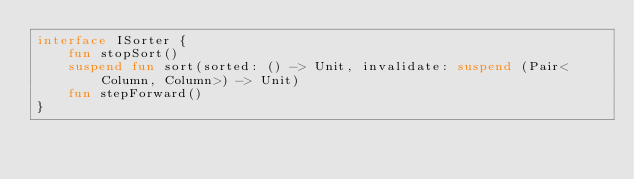<code> <loc_0><loc_0><loc_500><loc_500><_Kotlin_>interface ISorter {
    fun stopSort()
    suspend fun sort(sorted: () -> Unit, invalidate: suspend (Pair<Column, Column>) -> Unit)
    fun stepForward()
}</code> 